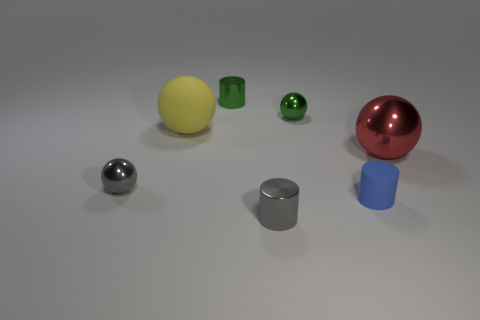How big is the gray thing on the left side of the yellow rubber sphere left of the small blue cylinder?
Your answer should be very brief. Small. How many other things are there of the same size as the green shiny cylinder?
Keep it short and to the point. 4. There is a small green sphere; what number of blue objects are behind it?
Provide a short and direct response. 0. How big is the green shiny cylinder?
Provide a succinct answer. Small. Is the tiny gray thing in front of the rubber cylinder made of the same material as the cylinder that is behind the small gray sphere?
Give a very brief answer. Yes. Are there any spheres that have the same color as the small rubber object?
Your answer should be very brief. No. What is the color of the rubber cylinder that is the same size as the gray metallic cylinder?
Provide a short and direct response. Blue. Is the color of the big thing right of the small matte object the same as the large matte ball?
Your answer should be compact. No. Are there any yellow things made of the same material as the gray ball?
Offer a terse response. No. Are there fewer small blue objects in front of the blue cylinder than yellow matte objects?
Give a very brief answer. Yes. 